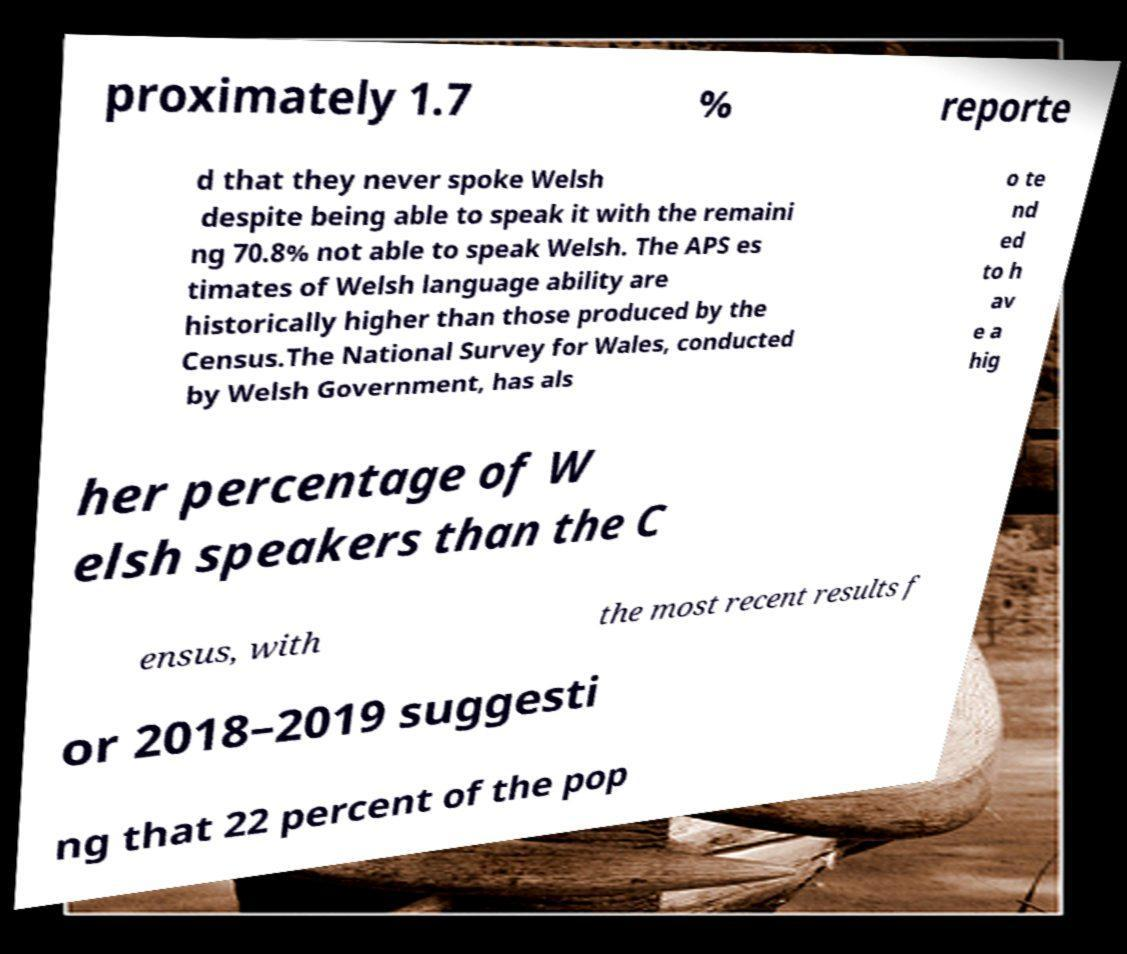Could you assist in decoding the text presented in this image and type it out clearly? proximately 1.7 % reporte d that they never spoke Welsh despite being able to speak it with the remaini ng 70.8% not able to speak Welsh. The APS es timates of Welsh language ability are historically higher than those produced by the Census.The National Survey for Wales, conducted by Welsh Government, has als o te nd ed to h av e a hig her percentage of W elsh speakers than the C ensus, with the most recent results f or 2018–2019 suggesti ng that 22 percent of the pop 